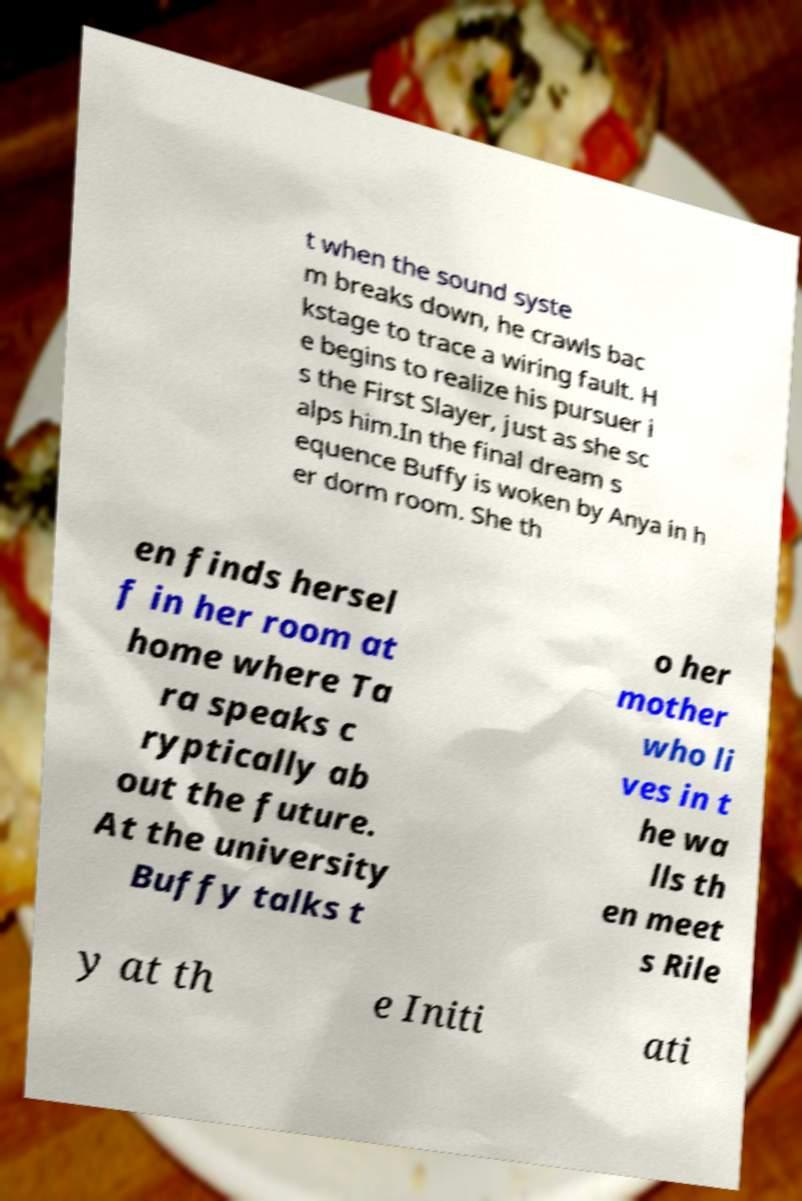Please identify and transcribe the text found in this image. t when the sound syste m breaks down, he crawls bac kstage to trace a wiring fault. H e begins to realize his pursuer i s the First Slayer, just as she sc alps him.In the final dream s equence Buffy is woken by Anya in h er dorm room. She th en finds hersel f in her room at home where Ta ra speaks c ryptically ab out the future. At the university Buffy talks t o her mother who li ves in t he wa lls th en meet s Rile y at th e Initi ati 